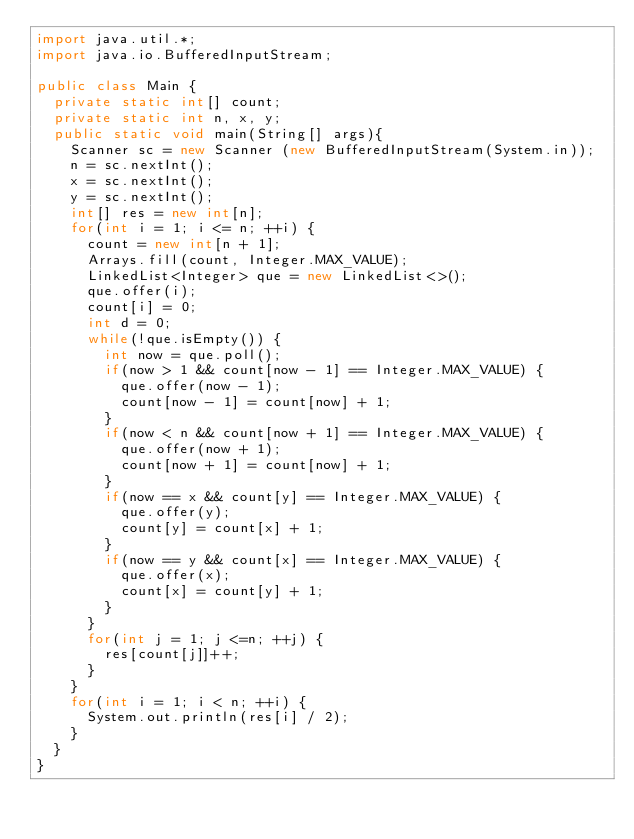Convert code to text. <code><loc_0><loc_0><loc_500><loc_500><_Java_>import java.util.*;
import java.io.BufferedInputStream;
 
public class Main {
  private static int[] count;
  private static int n, x, y;
  public static void main(String[] args){
    Scanner sc = new Scanner (new BufferedInputStream(System.in));
    n = sc.nextInt();
    x = sc.nextInt();
    y = sc.nextInt();
    int[] res = new int[n];
    for(int i = 1; i <= n; ++i) {
      count = new int[n + 1];
      Arrays.fill(count, Integer.MAX_VALUE);
      LinkedList<Integer> que = new LinkedList<>();
      que.offer(i);
      count[i] = 0;
      int d = 0;
      while(!que.isEmpty()) {
        int now = que.poll();
        if(now > 1 && count[now - 1] == Integer.MAX_VALUE) {
          que.offer(now - 1);
          count[now - 1] = count[now] + 1;
        }
        if(now < n && count[now + 1] == Integer.MAX_VALUE) {
          que.offer(now + 1);
          count[now + 1] = count[now] + 1;
        }
        if(now == x && count[y] == Integer.MAX_VALUE) {
          que.offer(y);
          count[y] = count[x] + 1;
        }
        if(now == y && count[x] == Integer.MAX_VALUE) {
          que.offer(x);
          count[x] = count[y] + 1;
        }
      }
      for(int j = 1; j <=n; ++j) {
        res[count[j]]++;
      }
    }
    for(int i = 1; i < n; ++i) {
      System.out.println(res[i] / 2);
    }
  }
}
</code> 